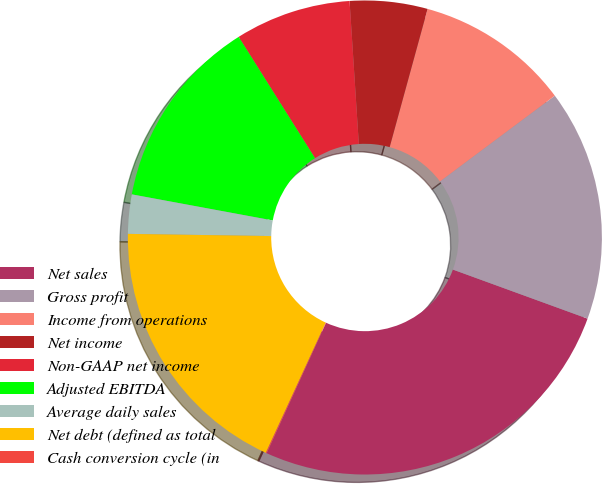Convert chart to OTSL. <chart><loc_0><loc_0><loc_500><loc_500><pie_chart><fcel>Net sales<fcel>Gross profit<fcel>Income from operations<fcel>Net income<fcel>Non-GAAP net income<fcel>Adjusted EBITDA<fcel>Average daily sales<fcel>Net debt (defined as total<fcel>Cash conversion cycle (in<nl><fcel>26.24%<fcel>15.77%<fcel>10.53%<fcel>5.29%<fcel>7.91%<fcel>13.15%<fcel>2.67%<fcel>18.38%<fcel>0.06%<nl></chart> 